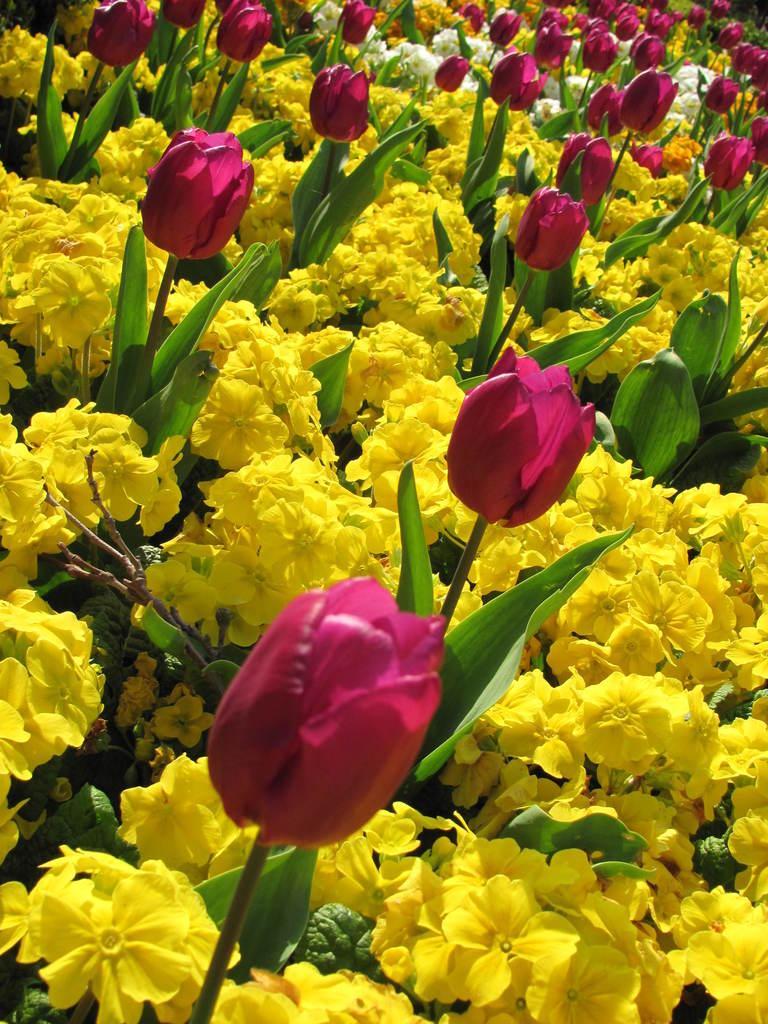Please provide a concise description of this image. In this image there are many yellow flower, there are pink tulips, in the background there are few white flowers. 